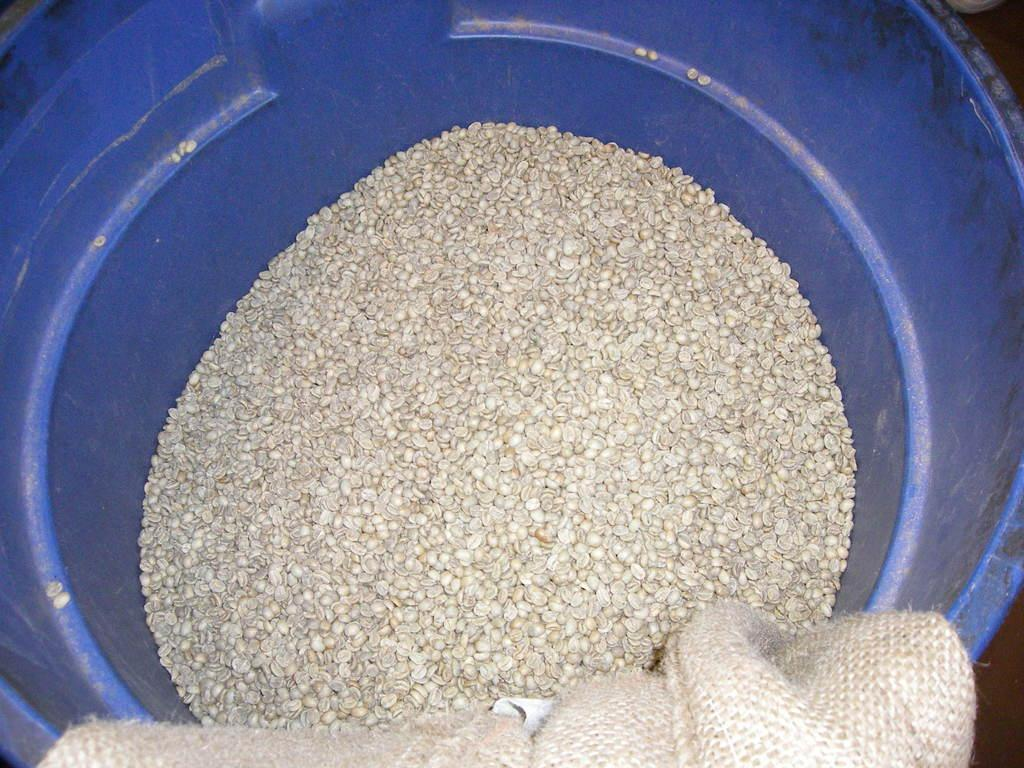What is the main object in the image? There is a tub in the image. What is inside the tub? There are tiny objects in the tub. What is located at the bottom of the image? There is a bag at the bottom of the image. How many jellyfish can be seen swimming in the tub? There are no jellyfish present in the image; it features a tub with tiny objects inside. 